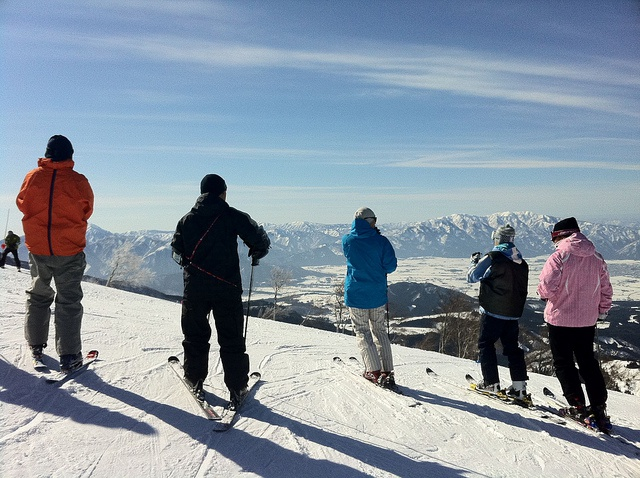Describe the objects in this image and their specific colors. I can see people in gray, black, and maroon tones, people in gray, black, lightgray, and darkgray tones, people in gray, black, and purple tones, people in gray, black, darkgray, and navy tones, and people in gray, navy, darkgray, and black tones in this image. 